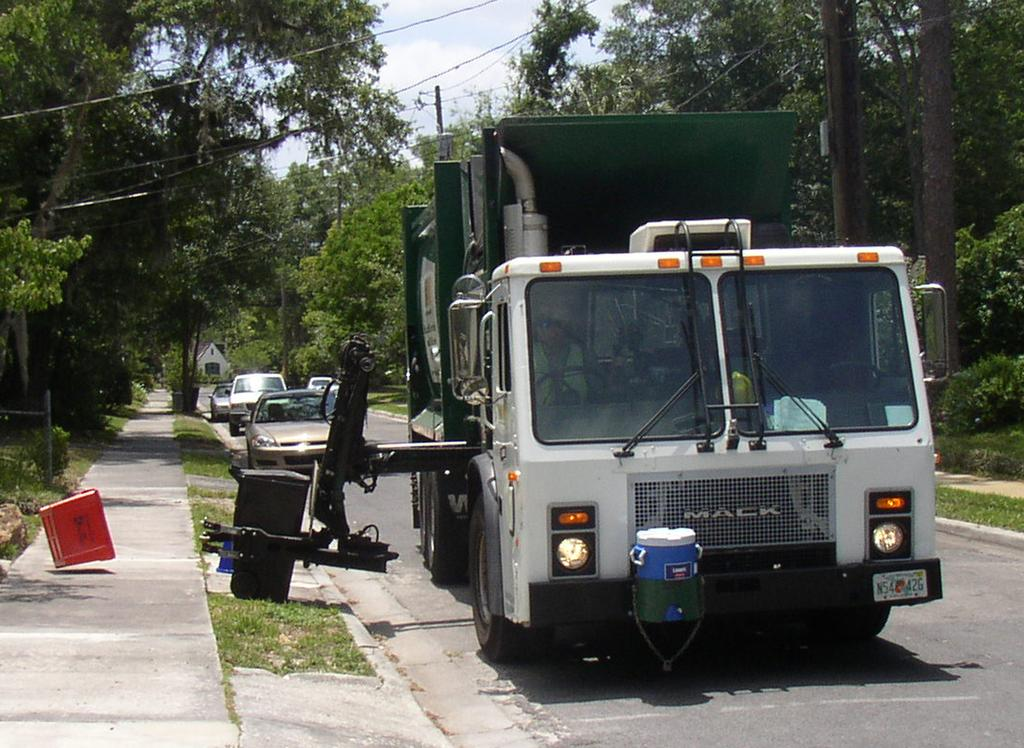What can be seen on the road in the image? There are vehicles on the road in the image. What type of natural elements are visible in the image? There are trees visible in the image. What else can be seen in the image besides the vehicles and trees? There are wires in the image. What is visible in the background of the image? The sky is visible in the background of the image. What type of structure can be seen in the image? There is a shed in the image. What type of pan is being used to cook food in the image? There is no pan or cooking activity present in the image. How does the behavior of the vehicles on the road affect the traffic in the image? The provided facts do not give information about the behavior of the vehicles or the traffic situation, so we cannot answer this question. 